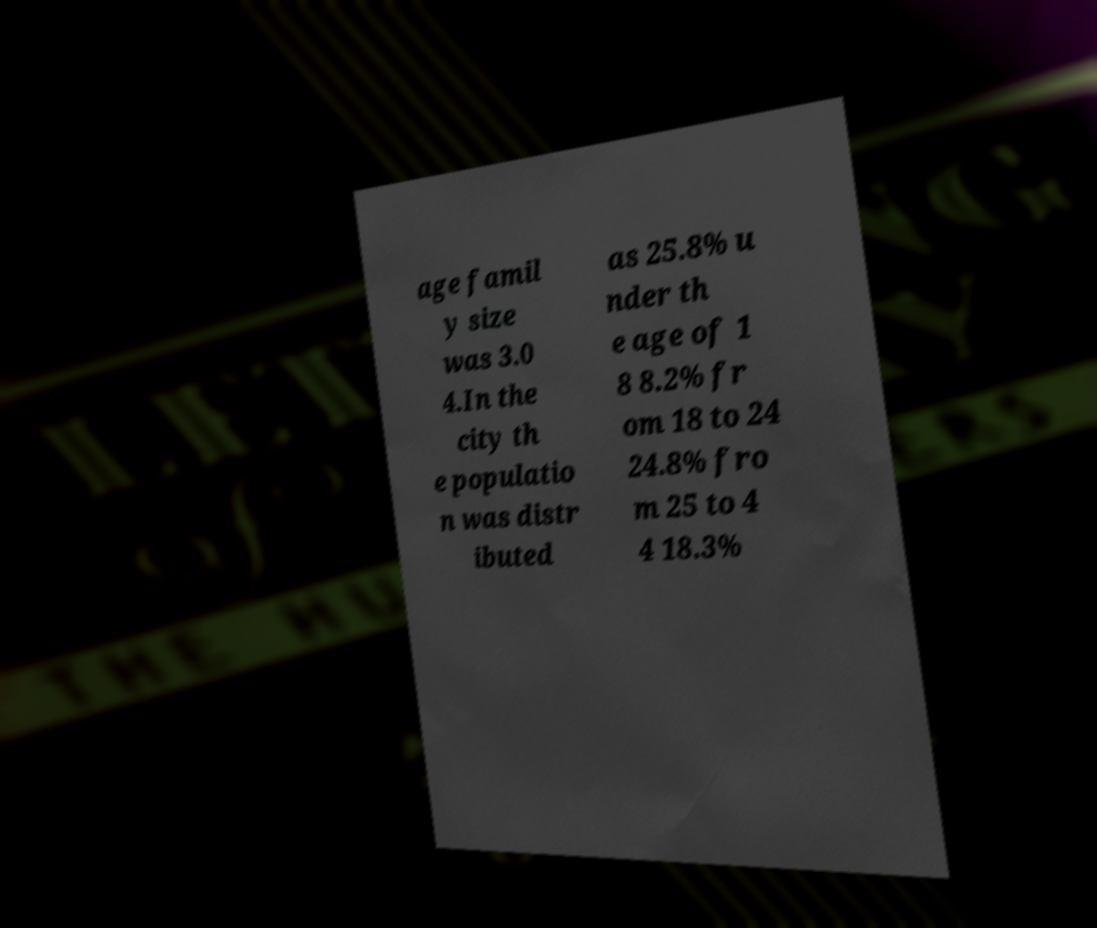What messages or text are displayed in this image? I need them in a readable, typed format. age famil y size was 3.0 4.In the city th e populatio n was distr ibuted as 25.8% u nder th e age of 1 8 8.2% fr om 18 to 24 24.8% fro m 25 to 4 4 18.3% 